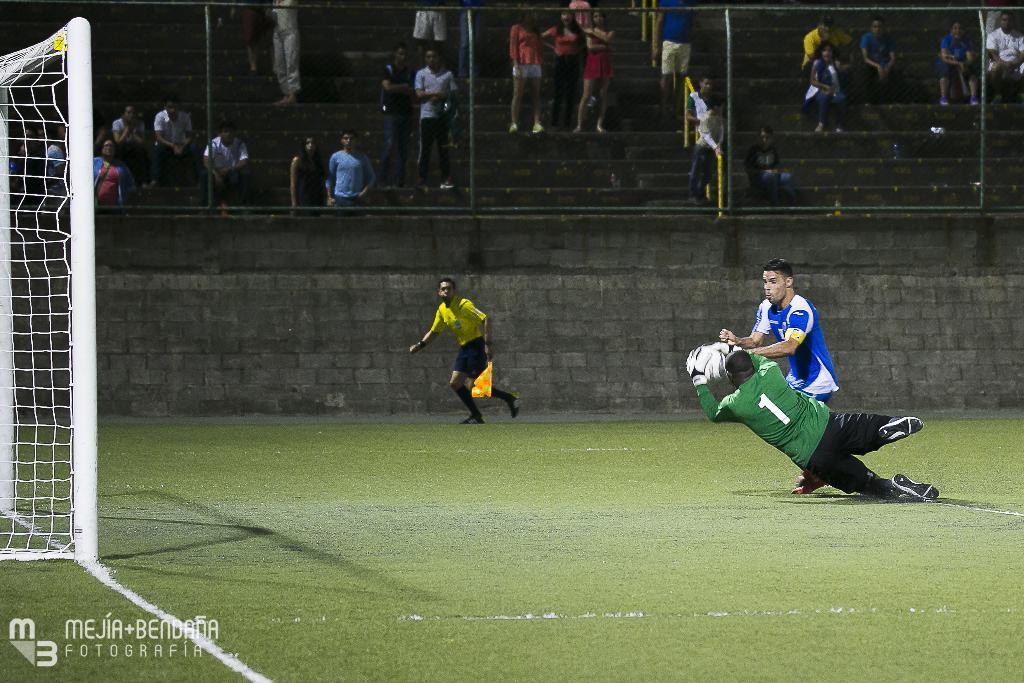What number is the jersey in green?
Make the answer very short. 1. What is the jersey number of the green jersey?
Keep it short and to the point. 1. 